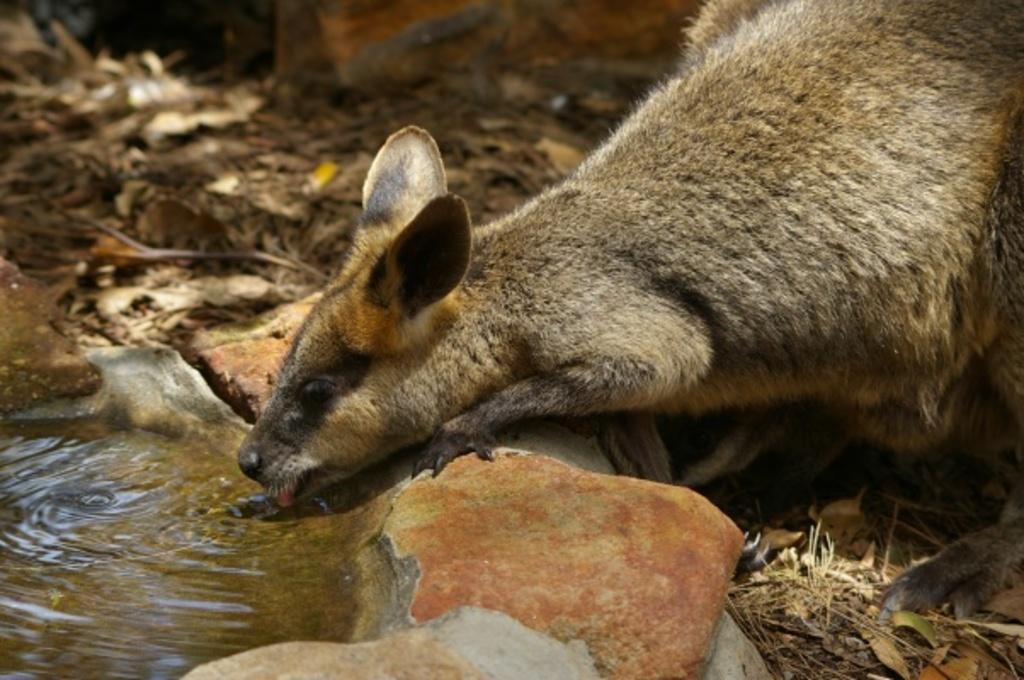Could you give a brief overview of what you see in this image? In the picture we can see an animal drinking water and around the water we can see some rocks and behind it we can see some twigs, and dried leaves on the surface. 